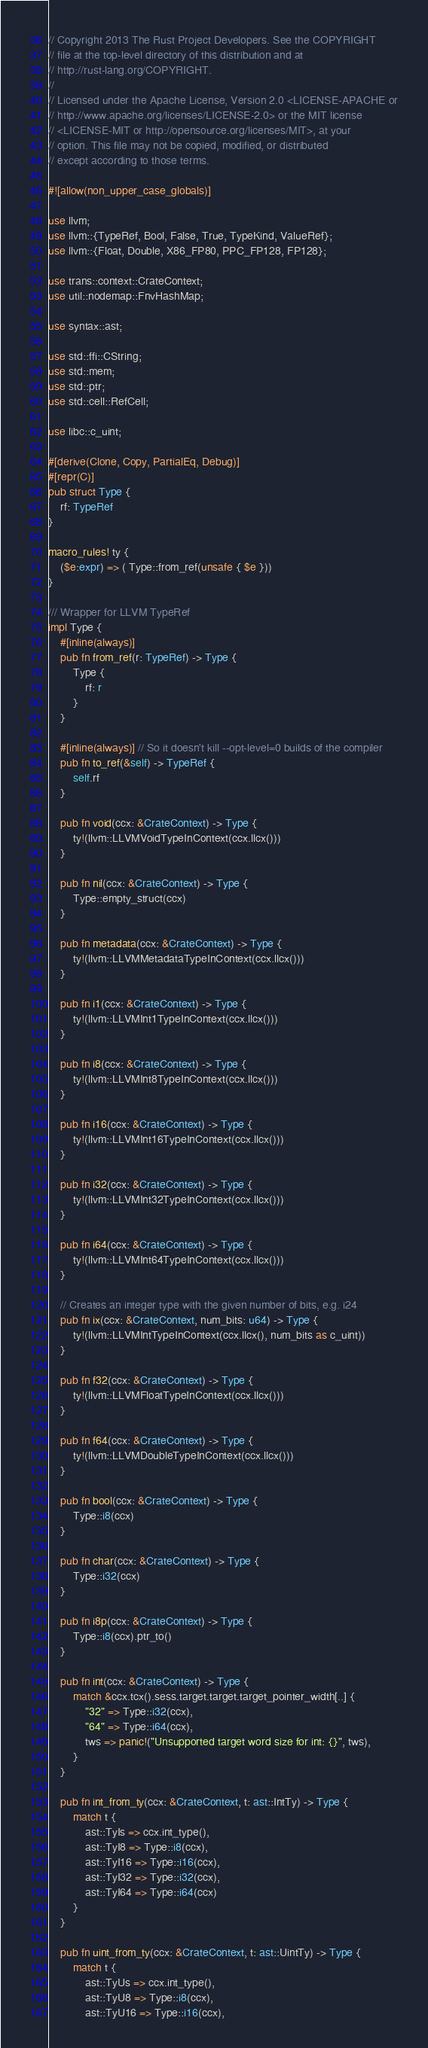<code> <loc_0><loc_0><loc_500><loc_500><_Rust_>// Copyright 2013 The Rust Project Developers. See the COPYRIGHT
// file at the top-level directory of this distribution and at
// http://rust-lang.org/COPYRIGHT.
//
// Licensed under the Apache License, Version 2.0 <LICENSE-APACHE or
// http://www.apache.org/licenses/LICENSE-2.0> or the MIT license
// <LICENSE-MIT or http://opensource.org/licenses/MIT>, at your
// option. This file may not be copied, modified, or distributed
// except according to those terms.

#![allow(non_upper_case_globals)]

use llvm;
use llvm::{TypeRef, Bool, False, True, TypeKind, ValueRef};
use llvm::{Float, Double, X86_FP80, PPC_FP128, FP128};

use trans::context::CrateContext;
use util::nodemap::FnvHashMap;

use syntax::ast;

use std::ffi::CString;
use std::mem;
use std::ptr;
use std::cell::RefCell;

use libc::c_uint;

#[derive(Clone, Copy, PartialEq, Debug)]
#[repr(C)]
pub struct Type {
    rf: TypeRef
}

macro_rules! ty {
    ($e:expr) => ( Type::from_ref(unsafe { $e }))
}

/// Wrapper for LLVM TypeRef
impl Type {
    #[inline(always)]
    pub fn from_ref(r: TypeRef) -> Type {
        Type {
            rf: r
        }
    }

    #[inline(always)] // So it doesn't kill --opt-level=0 builds of the compiler
    pub fn to_ref(&self) -> TypeRef {
        self.rf
    }

    pub fn void(ccx: &CrateContext) -> Type {
        ty!(llvm::LLVMVoidTypeInContext(ccx.llcx()))
    }

    pub fn nil(ccx: &CrateContext) -> Type {
        Type::empty_struct(ccx)
    }

    pub fn metadata(ccx: &CrateContext) -> Type {
        ty!(llvm::LLVMMetadataTypeInContext(ccx.llcx()))
    }

    pub fn i1(ccx: &CrateContext) -> Type {
        ty!(llvm::LLVMInt1TypeInContext(ccx.llcx()))
    }

    pub fn i8(ccx: &CrateContext) -> Type {
        ty!(llvm::LLVMInt8TypeInContext(ccx.llcx()))
    }

    pub fn i16(ccx: &CrateContext) -> Type {
        ty!(llvm::LLVMInt16TypeInContext(ccx.llcx()))
    }

    pub fn i32(ccx: &CrateContext) -> Type {
        ty!(llvm::LLVMInt32TypeInContext(ccx.llcx()))
    }

    pub fn i64(ccx: &CrateContext) -> Type {
        ty!(llvm::LLVMInt64TypeInContext(ccx.llcx()))
    }

    // Creates an integer type with the given number of bits, e.g. i24
    pub fn ix(ccx: &CrateContext, num_bits: u64) -> Type {
        ty!(llvm::LLVMIntTypeInContext(ccx.llcx(), num_bits as c_uint))
    }

    pub fn f32(ccx: &CrateContext) -> Type {
        ty!(llvm::LLVMFloatTypeInContext(ccx.llcx()))
    }

    pub fn f64(ccx: &CrateContext) -> Type {
        ty!(llvm::LLVMDoubleTypeInContext(ccx.llcx()))
    }

    pub fn bool(ccx: &CrateContext) -> Type {
        Type::i8(ccx)
    }

    pub fn char(ccx: &CrateContext) -> Type {
        Type::i32(ccx)
    }

    pub fn i8p(ccx: &CrateContext) -> Type {
        Type::i8(ccx).ptr_to()
    }

    pub fn int(ccx: &CrateContext) -> Type {
        match &ccx.tcx().sess.target.target.target_pointer_width[..] {
            "32" => Type::i32(ccx),
            "64" => Type::i64(ccx),
            tws => panic!("Unsupported target word size for int: {}", tws),
        }
    }

    pub fn int_from_ty(ccx: &CrateContext, t: ast::IntTy) -> Type {
        match t {
            ast::TyIs => ccx.int_type(),
            ast::TyI8 => Type::i8(ccx),
            ast::TyI16 => Type::i16(ccx),
            ast::TyI32 => Type::i32(ccx),
            ast::TyI64 => Type::i64(ccx)
        }
    }

    pub fn uint_from_ty(ccx: &CrateContext, t: ast::UintTy) -> Type {
        match t {
            ast::TyUs => ccx.int_type(),
            ast::TyU8 => Type::i8(ccx),
            ast::TyU16 => Type::i16(ccx),</code> 